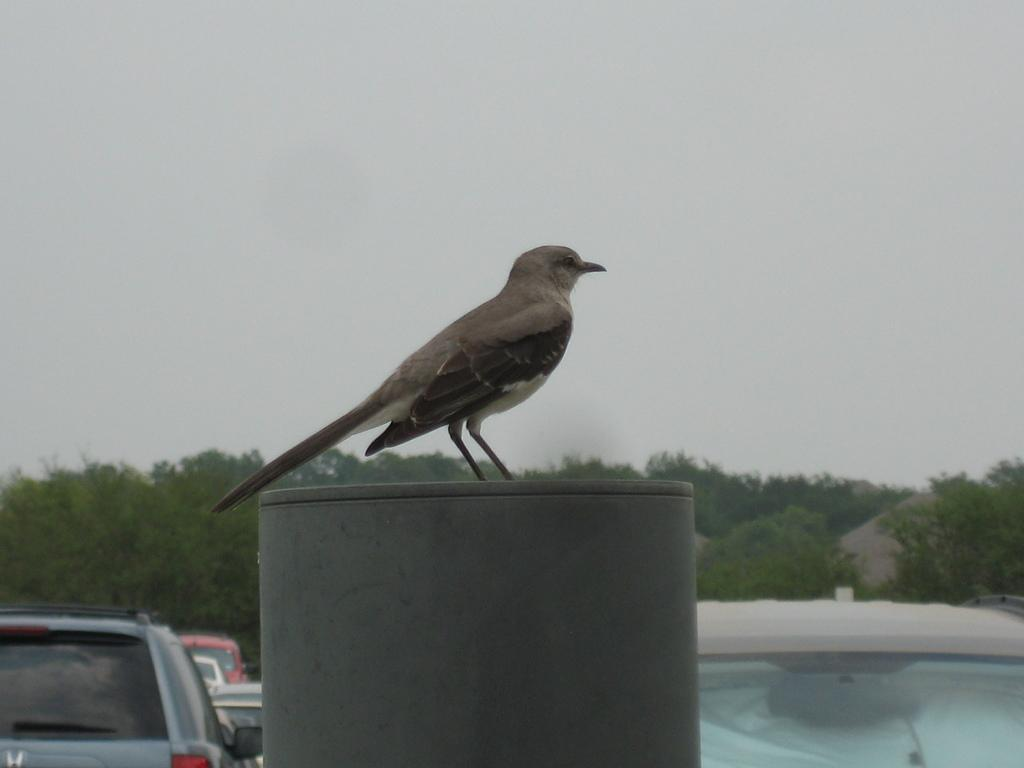What type of animal is in the image? There is a bird in the image. Where is the bird located? The bird is on a cylindrical structure. What else can be seen in the image besides the bird? Cars, trees, and rocks are visible in the image. What type of meal is the bird eating in the image? There is no meal present in the image, and the bird is not shown eating anything. 